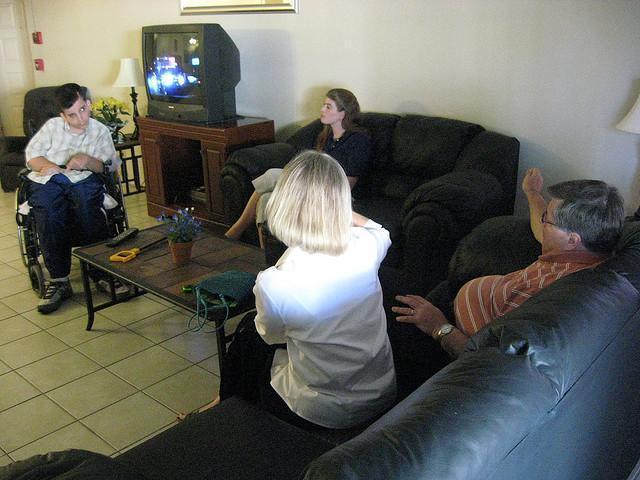How many people are there?
Give a very brief answer. 4. How many couches can you see?
Give a very brief answer. 2. How many people can you see?
Give a very brief answer. 4. How many horses are there?
Give a very brief answer. 0. 